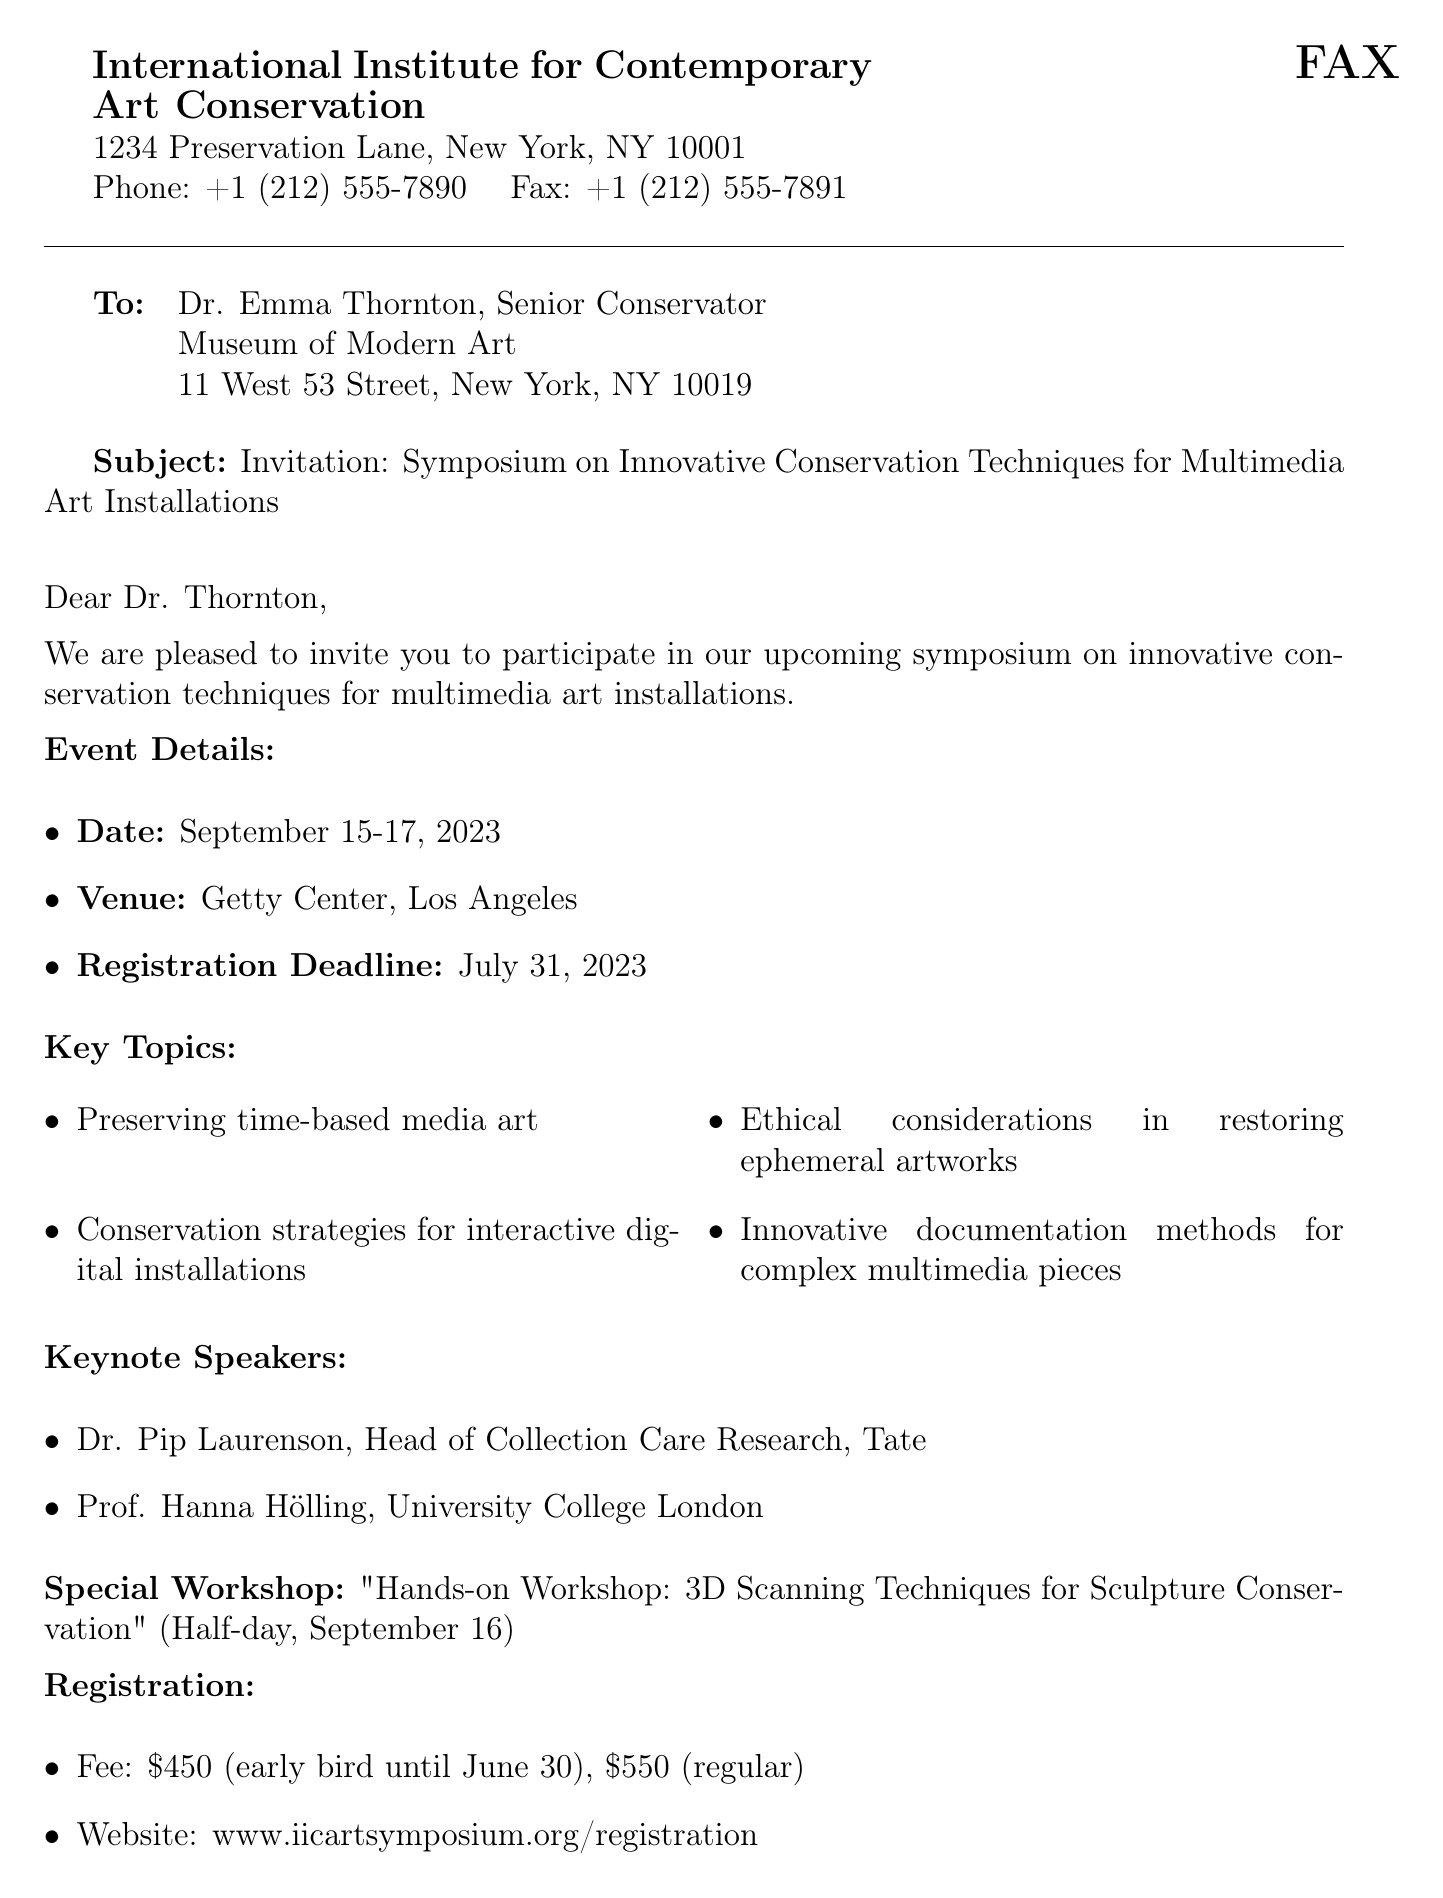What are the dates of the symposium? The document lists the event dates as September 15-17, 2023.
Answer: September 15-17, 2023 Who is invited to the symposium? The letter is addressed to Dr. Emma Thornton, indicating she is invited to participate in the symposium.
Answer: Dr. Emma Thornton What is the registration deadline? The document specifies that the registration deadline is July 31, 2023.
Answer: July 31, 2023 What is the fee for early bird registration? The document states that the early bird fee is $450 until June 30.
Answer: $450 What is one key topic of the symposium? The document lists various topics, one of which is "Preserving time-based media art."
Answer: Preserving time-based media art Who is one of the keynote speakers? The document mentions Dr. Pip Laurenson as one of the keynote speakers.
Answer: Dr. Pip Laurenson What is the venue for the event? The venue for the symposium is noted as the Getty Center in Los Angeles.
Answer: Getty Center, Los Angeles What special workshop is offered? The document highlights a hands-on workshop on "3D Scanning Techniques for Sculpture Conservation."
Answer: "Hands-on Workshop: 3D Scanning Techniques for Sculpture Conservation" What is the contact email for further information? The document provides the email address symposium@iicart.org for inquiries.
Answer: symposium@iicart.org 